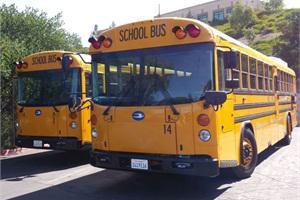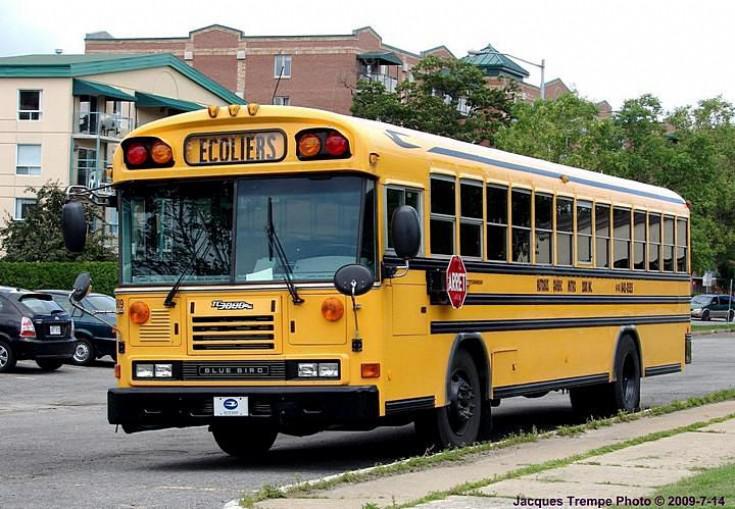The first image is the image on the left, the second image is the image on the right. Given the left and right images, does the statement "One of the images features two school buses beside each other and the other image shows a single school bus." hold true? Answer yes or no. Yes. The first image is the image on the left, the second image is the image on the right. Considering the images on both sides, is "The school buses in both pictures are facing left." valid? Answer yes or no. Yes. 